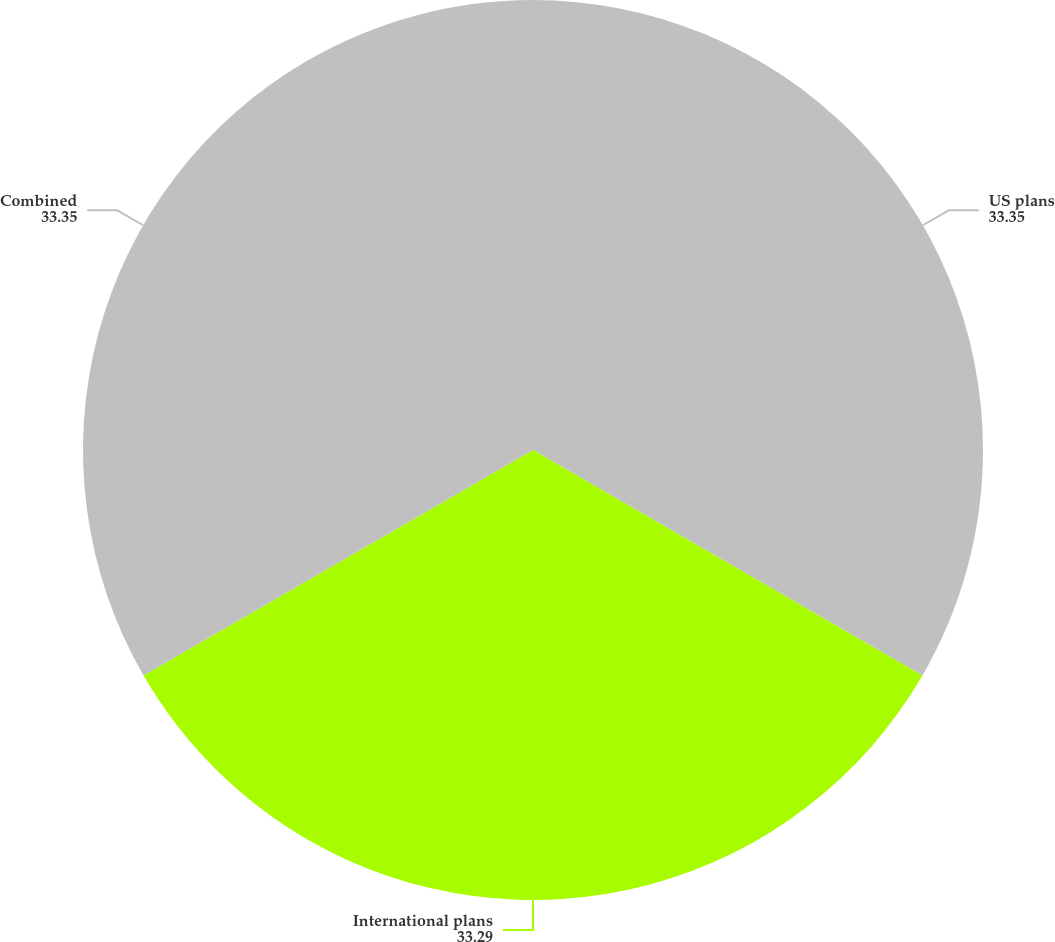<chart> <loc_0><loc_0><loc_500><loc_500><pie_chart><fcel>US plans<fcel>International plans<fcel>Combined<nl><fcel>33.35%<fcel>33.29%<fcel>33.35%<nl></chart> 